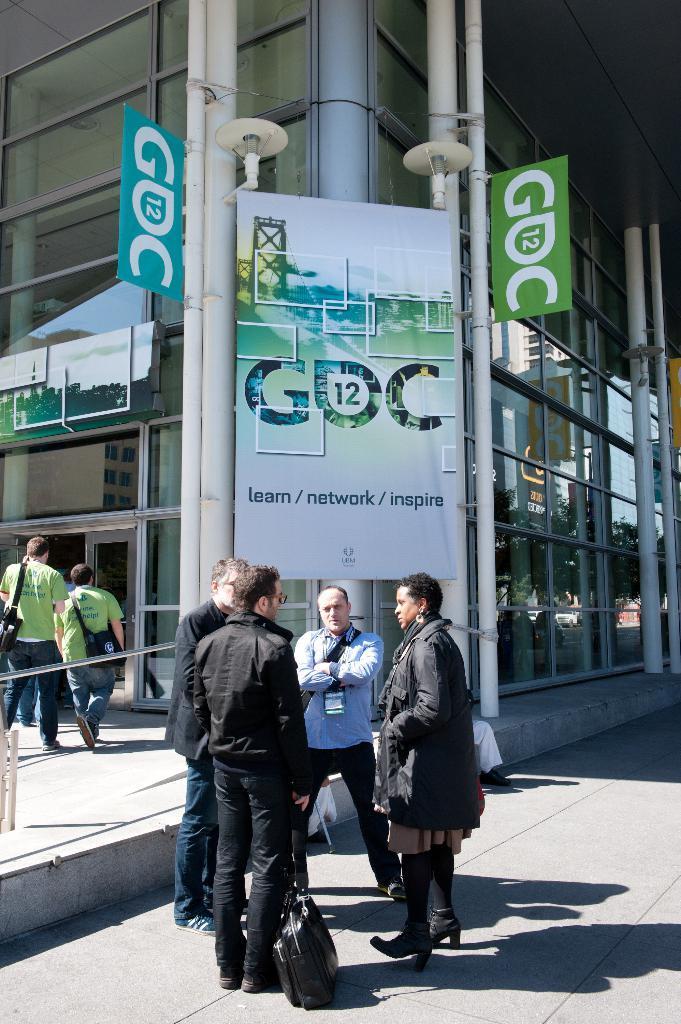In one or two sentences, can you explain what this image depicts? In this image we can see a building with glasses. On the building we can see the banners and we can see the text in the banners. In the foreground we can see few persons and a bag on the surface. On the left side, we can few persons walking and carrying bags. On the right side, we can see the pillars and we can see the reflection of trees in the glass of the building. 